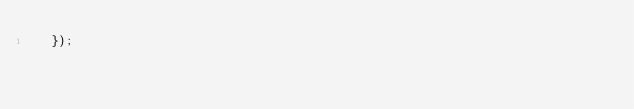Convert code to text. <code><loc_0><loc_0><loc_500><loc_500><_JavaScript_>  });
</code> 